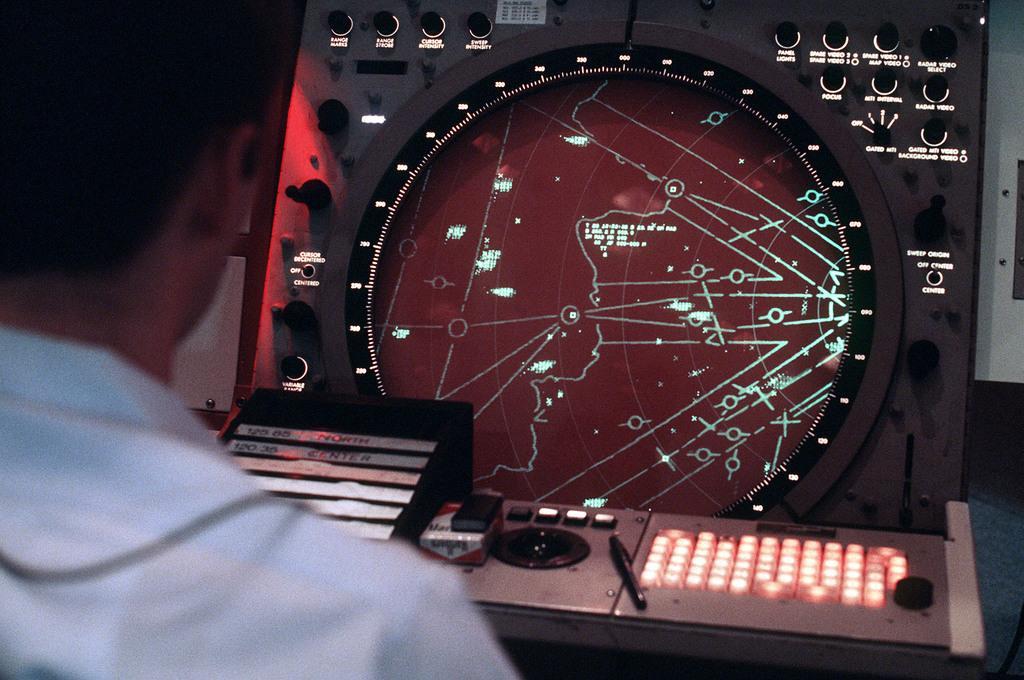Can you describe this image briefly? In this image we can able to see a person, in front of him there is a machine with switches on it, and we can see a pen on the surface. 